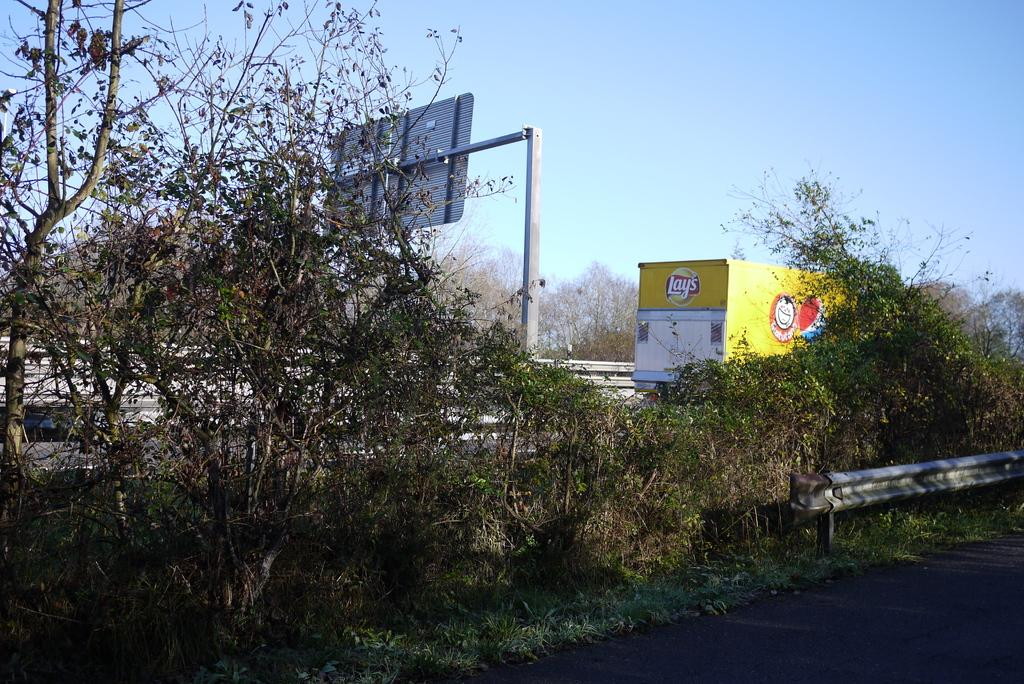What is located at the bottom of the image? There is a road at the bottom of the image. What can be seen in the image besides the road? There is a small fence, plants, grass, a vehicle, a board on a pole stand, a fence in the background, trees, and the sky visible in the background. Can you describe the vegetation in the image? Plants and trees are present in the image. What type of ground surface is visible in the image? Grass is visible on the ground. What is the background of the image composed of? The background of the image includes a vehicle, a board on a pole stand, a fence, trees, and the sky. How many bells are hanging from the fence in the image? There are no bells present in the image. What is your uncle doing in the image? There is no person, including an uncle, present in the image. 